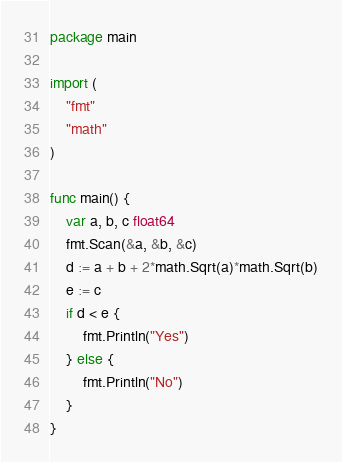<code> <loc_0><loc_0><loc_500><loc_500><_Go_>package main

import (
	"fmt"
	"math"
)

func main() {
	var a, b, c float64
	fmt.Scan(&a, &b, &c)
	d := a + b + 2*math.Sqrt(a)*math.Sqrt(b)
	e := c
	if d < e {
		fmt.Println("Yes")
	} else {
		fmt.Println("No")
	}
}
</code> 